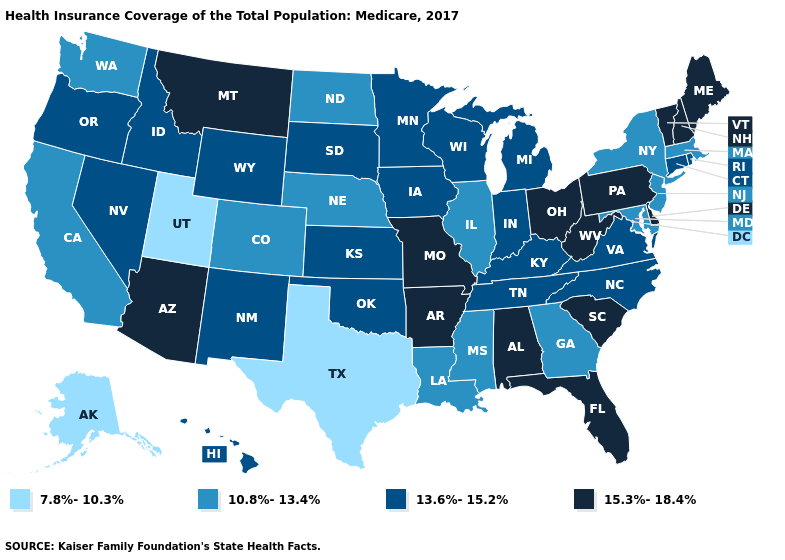Among the states that border New York , does Pennsylvania have the highest value?
Give a very brief answer. Yes. What is the highest value in states that border Utah?
Be succinct. 15.3%-18.4%. Does Missouri have the highest value in the USA?
Keep it brief. Yes. Name the states that have a value in the range 10.8%-13.4%?
Concise answer only. California, Colorado, Georgia, Illinois, Louisiana, Maryland, Massachusetts, Mississippi, Nebraska, New Jersey, New York, North Dakota, Washington. What is the value of Hawaii?
Quick response, please. 13.6%-15.2%. Name the states that have a value in the range 15.3%-18.4%?
Keep it brief. Alabama, Arizona, Arkansas, Delaware, Florida, Maine, Missouri, Montana, New Hampshire, Ohio, Pennsylvania, South Carolina, Vermont, West Virginia. Name the states that have a value in the range 7.8%-10.3%?
Write a very short answer. Alaska, Texas, Utah. Among the states that border West Virginia , which have the highest value?
Write a very short answer. Ohio, Pennsylvania. What is the value of Hawaii?
Quick response, please. 13.6%-15.2%. What is the highest value in the MidWest ?
Keep it brief. 15.3%-18.4%. Name the states that have a value in the range 7.8%-10.3%?
Write a very short answer. Alaska, Texas, Utah. Does California have a lower value than Montana?
Answer briefly. Yes. Does Delaware have the same value as West Virginia?
Short answer required. Yes. What is the highest value in the USA?
Write a very short answer. 15.3%-18.4%. Does North Carolina have a lower value than Missouri?
Keep it brief. Yes. 